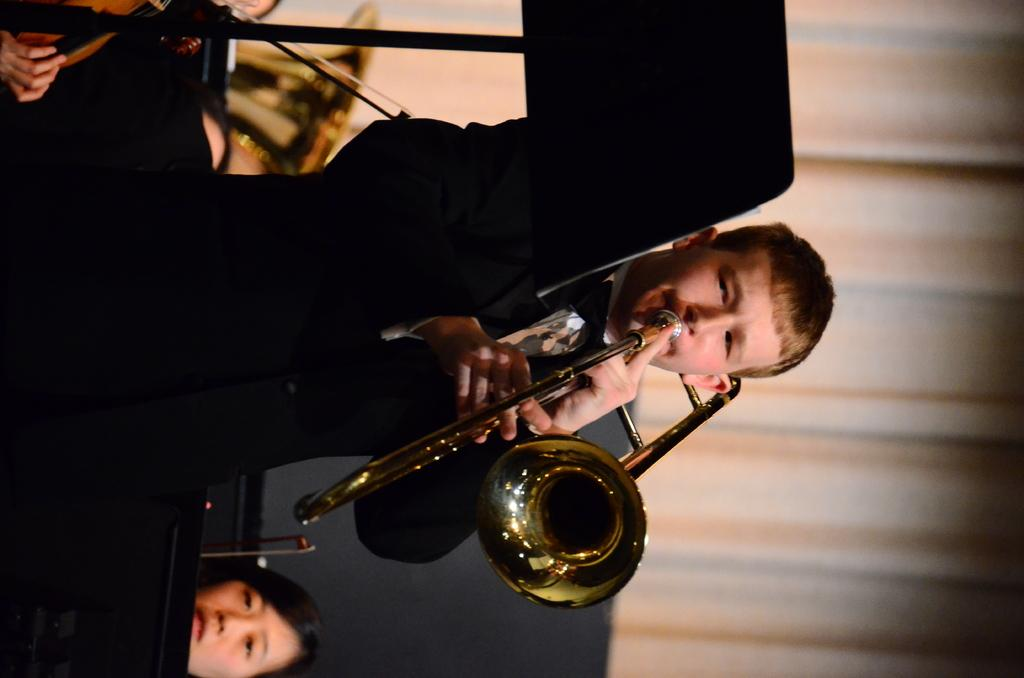What is the man in the image doing? The man is playing the tuba in the image. Can you describe the setting of the image? There are other people in the background of the image. What is one feature of the environment in the image? There is a curtain visible in the image. How much wealth does the cushion in the image possess? There is no cushion present in the image, so it is not possible to determine its wealth. 